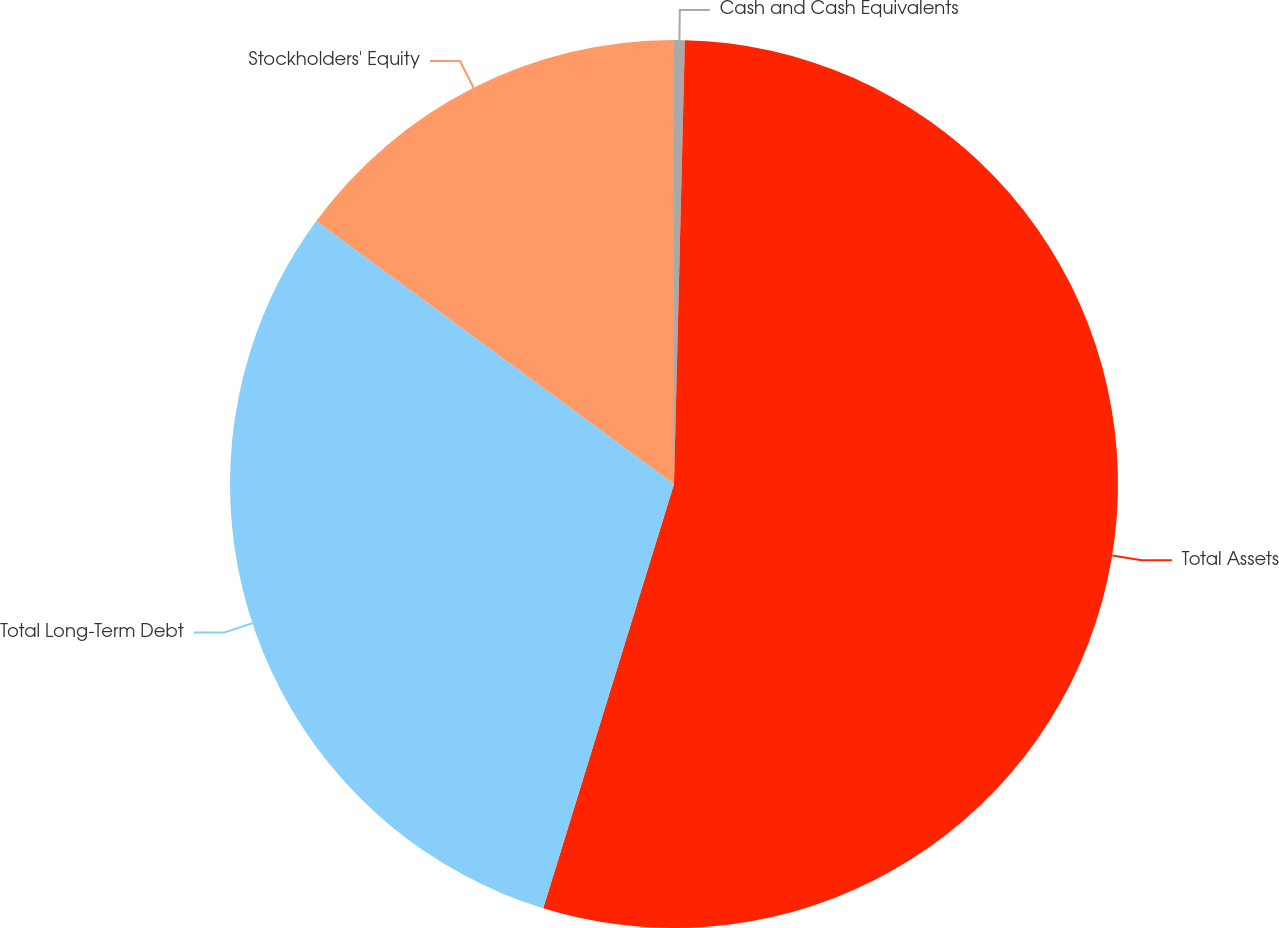<chart> <loc_0><loc_0><loc_500><loc_500><pie_chart><fcel>Cash and Cash Equivalents<fcel>Total Assets<fcel>Total Long-Term Debt<fcel>Stockholders' Equity<nl><fcel>0.39%<fcel>54.37%<fcel>30.33%<fcel>14.91%<nl></chart> 